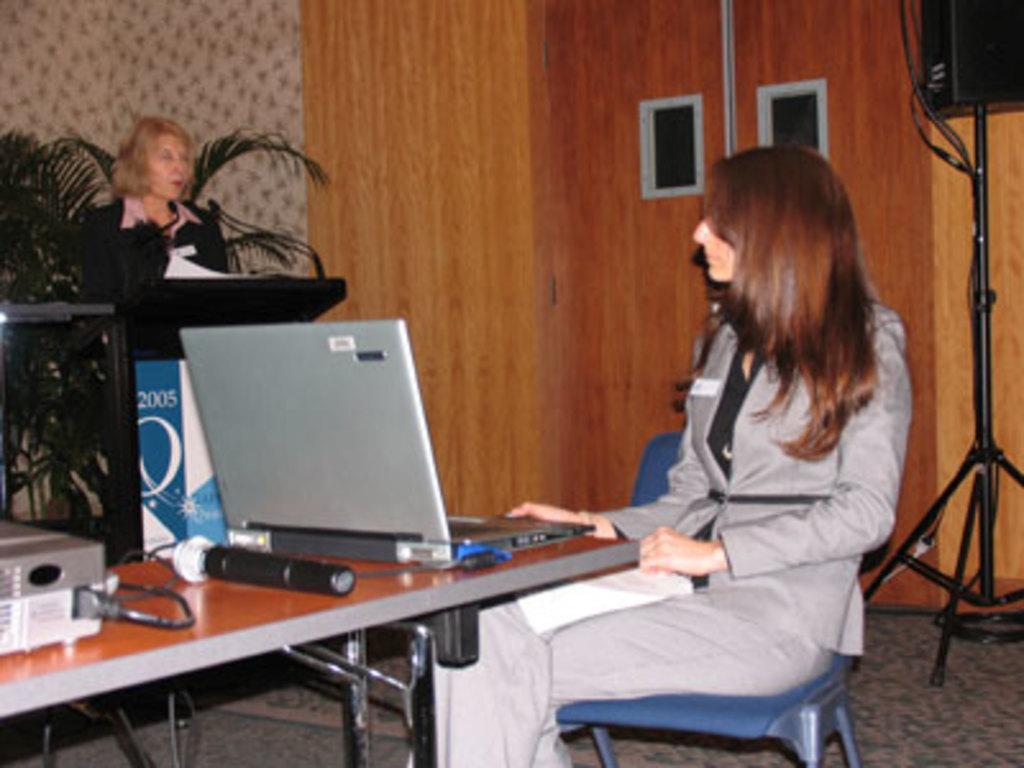Describe this image in one or two sentences. In this picture this person sitting on the chair. This person standing. This is podium. On the podium we can see microphone. On the background we can see wall,planter,speakers with stand. This is chair. There is a table. On the table we can see laptop,Microphone,cable. This is floor. 